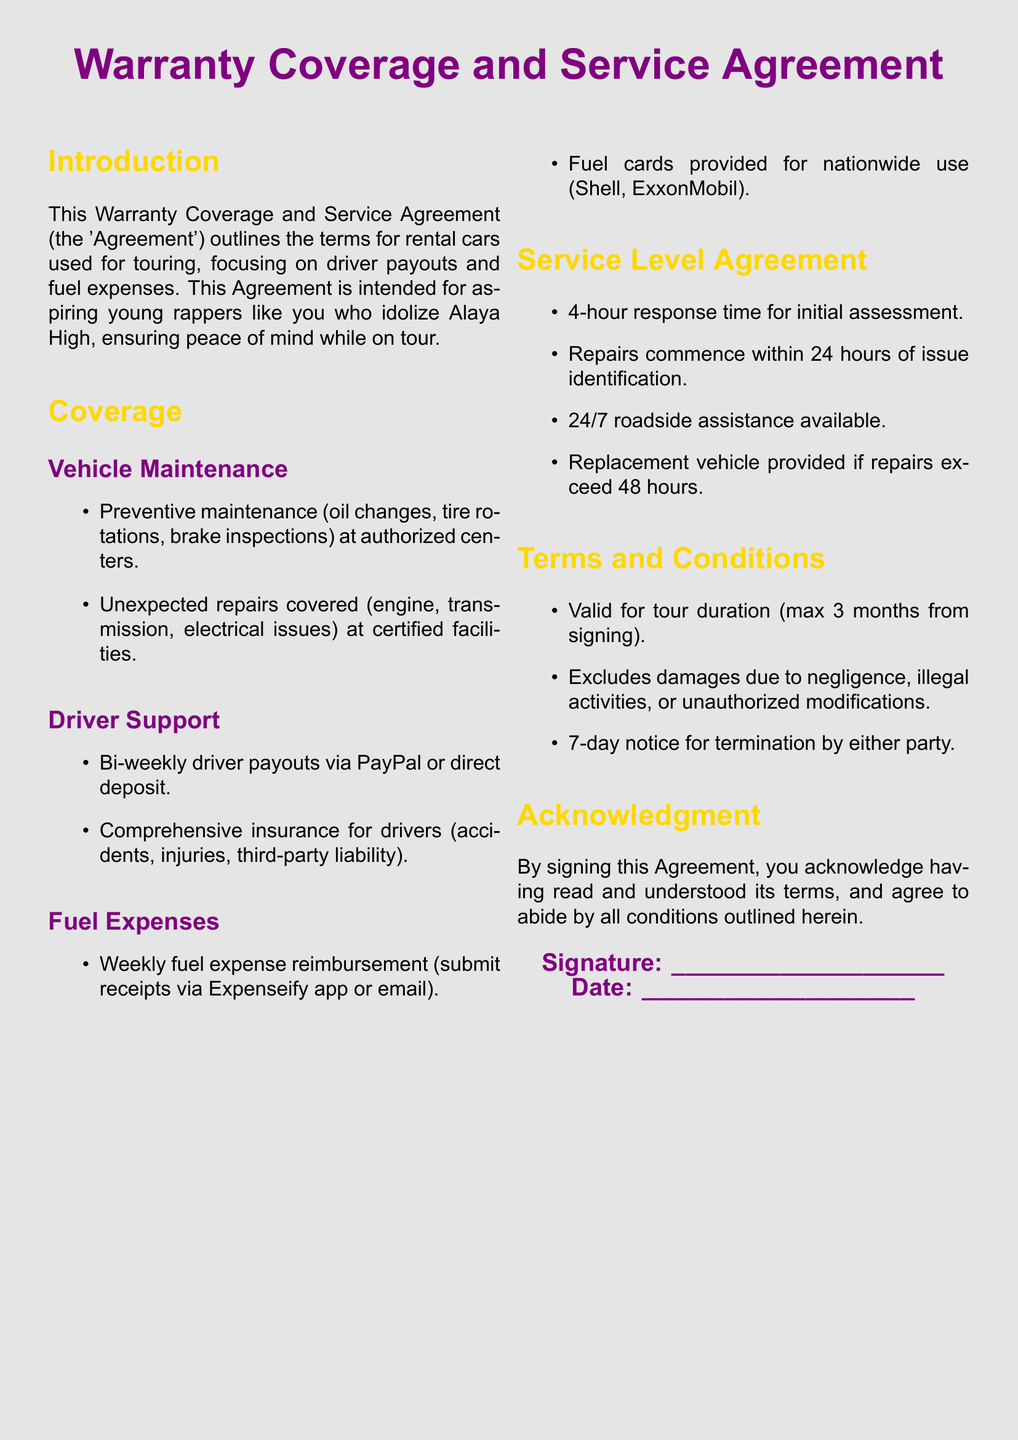What is the main purpose of the Agreement? The Agreement outlines the terms for rental cars used for touring, focusing on driver payouts and fuel expenses.
Answer: Terms for rental cars used for touring How often are driver payouts made? The Agreement specifies that driver payouts are made bi-weekly.
Answer: Bi-weekly What type of support is provided for drivers? The coverage includes comprehensive insurance for drivers.
Answer: Comprehensive insurance What is the maximum duration of the Agreement? The Agreement is valid for a maximum of 3 months from signing.
Answer: 3 months What is the response time for initial assessment? The document states that there is a 4-hour response time for initial assessment.
Answer: 4-hour What are the exclusions noted in the Terms and Conditions? The exclusions include damages due to negligence, illegal activities, or unauthorized modifications.
Answer: Negligence, illegal activities, unauthorized modifications When does a replacement vehicle get provided? A replacement vehicle is provided if repairs exceed 48 hours.
Answer: 48 hours What is required for fuel expense reimbursement? Receipts must be submitted via Expenseify app or email.
Answer: Receipts via Expenseify app or email What is included in preventive maintenance? Preventive maintenance includes oil changes, tire rotations, and brake inspections.
Answer: Oil changes, tire rotations, brake inspections 